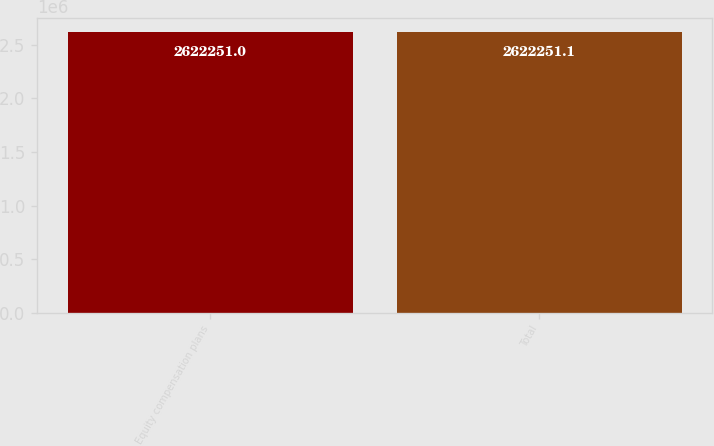<chart> <loc_0><loc_0><loc_500><loc_500><bar_chart><fcel>Equity compensation plans<fcel>Total<nl><fcel>2.62225e+06<fcel>2.62225e+06<nl></chart> 